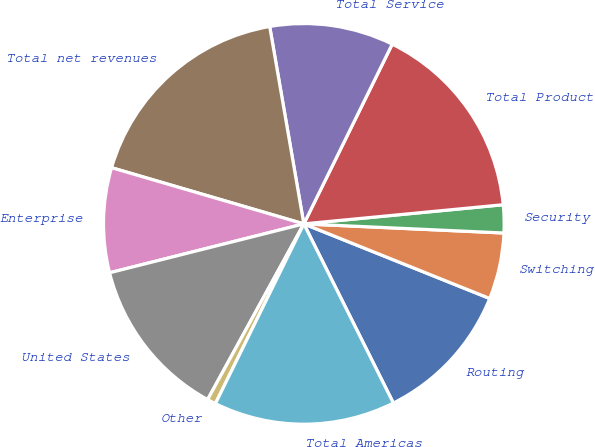Convert chart to OTSL. <chart><loc_0><loc_0><loc_500><loc_500><pie_chart><fcel>Routing<fcel>Switching<fcel>Security<fcel>Total Product<fcel>Total Service<fcel>Total net revenues<fcel>Enterprise<fcel>United States<fcel>Other<fcel>Total Americas<nl><fcel>11.55%<fcel>5.35%<fcel>2.25%<fcel>16.2%<fcel>10.0%<fcel>17.75%<fcel>8.45%<fcel>13.1%<fcel>0.7%<fcel>14.65%<nl></chart> 